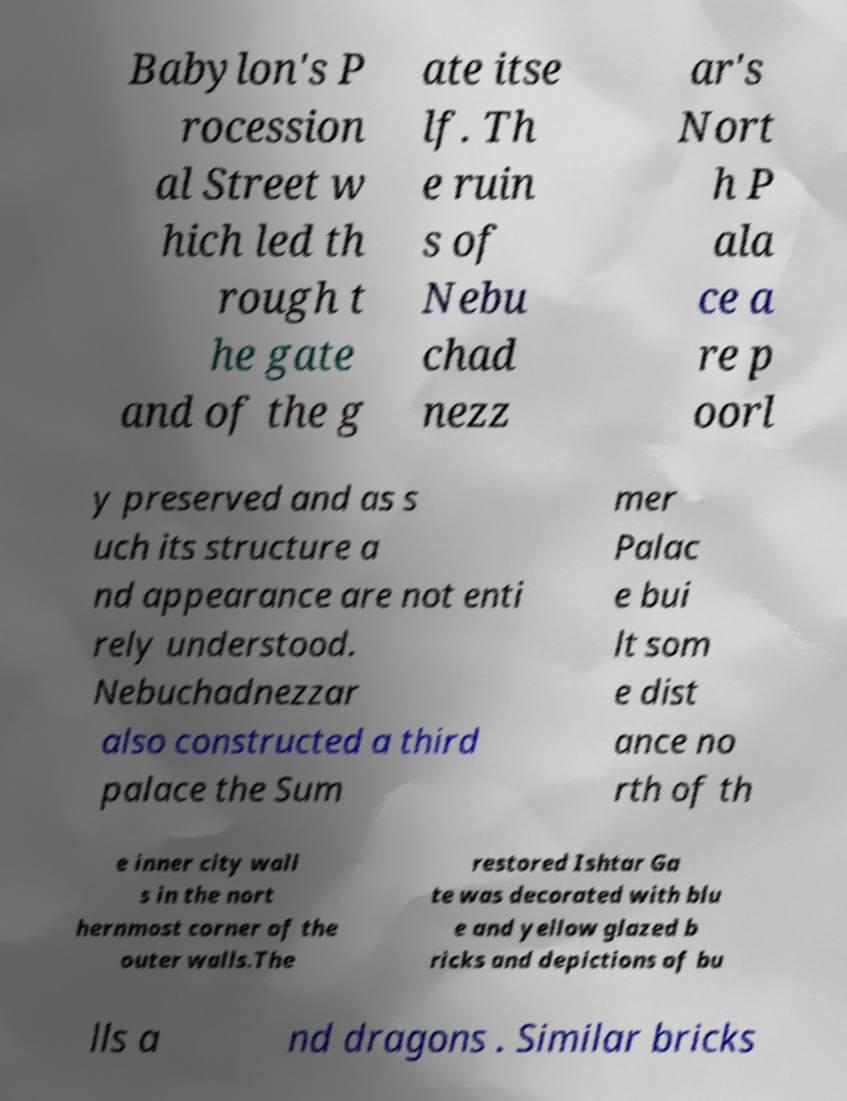What messages or text are displayed in this image? I need them in a readable, typed format. Babylon's P rocession al Street w hich led th rough t he gate and of the g ate itse lf. Th e ruin s of Nebu chad nezz ar's Nort h P ala ce a re p oorl y preserved and as s uch its structure a nd appearance are not enti rely understood. Nebuchadnezzar also constructed a third palace the Sum mer Palac e bui lt som e dist ance no rth of th e inner city wall s in the nort hernmost corner of the outer walls.The restored Ishtar Ga te was decorated with blu e and yellow glazed b ricks and depictions of bu lls a nd dragons . Similar bricks 